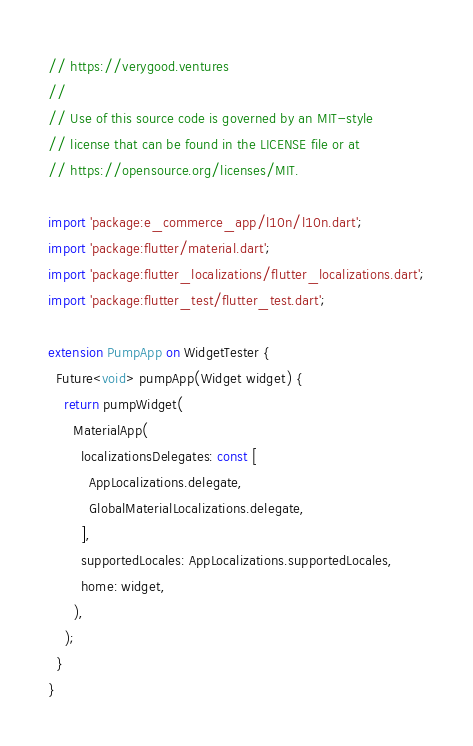Convert code to text. <code><loc_0><loc_0><loc_500><loc_500><_Dart_>// https://verygood.ventures
//
// Use of this source code is governed by an MIT-style
// license that can be found in the LICENSE file or at
// https://opensource.org/licenses/MIT.

import 'package:e_commerce_app/l10n/l10n.dart';
import 'package:flutter/material.dart';
import 'package:flutter_localizations/flutter_localizations.dart';
import 'package:flutter_test/flutter_test.dart';

extension PumpApp on WidgetTester {
  Future<void> pumpApp(Widget widget) {
    return pumpWidget(
      MaterialApp(
        localizationsDelegates: const [
          AppLocalizations.delegate,
          GlobalMaterialLocalizations.delegate,
        ],
        supportedLocales: AppLocalizations.supportedLocales,
        home: widget,
      ),
    );
  }
}
</code> 